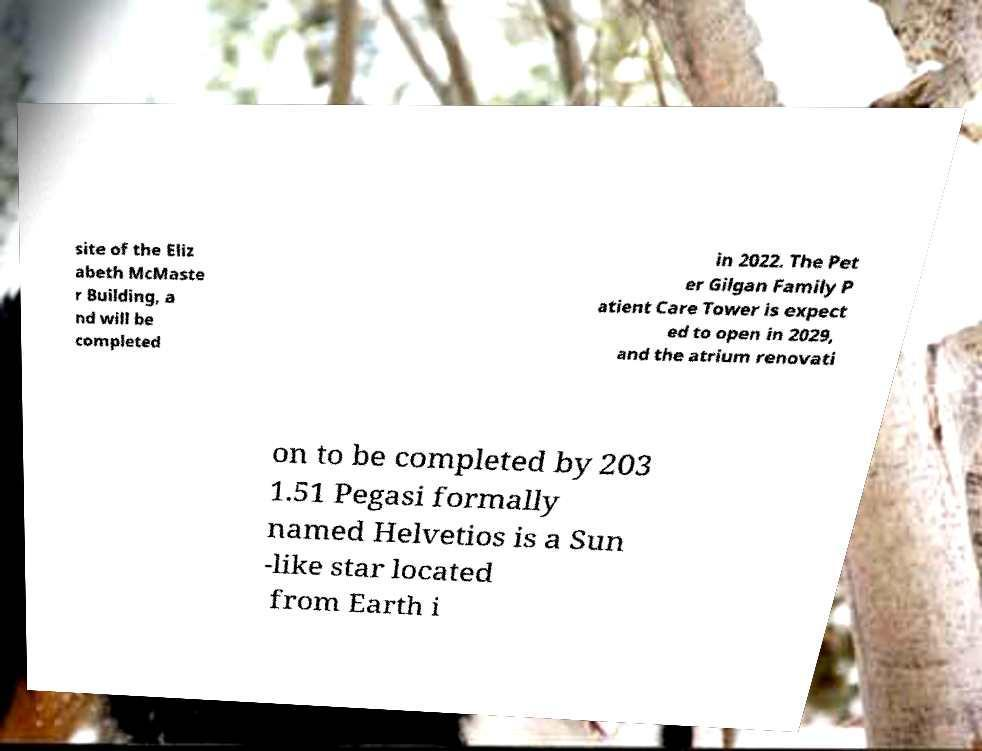Please identify and transcribe the text found in this image. site of the Eliz abeth McMaste r Building, a nd will be completed in 2022. The Pet er Gilgan Family P atient Care Tower is expect ed to open in 2029, and the atrium renovati on to be completed by 203 1.51 Pegasi formally named Helvetios is a Sun -like star located from Earth i 